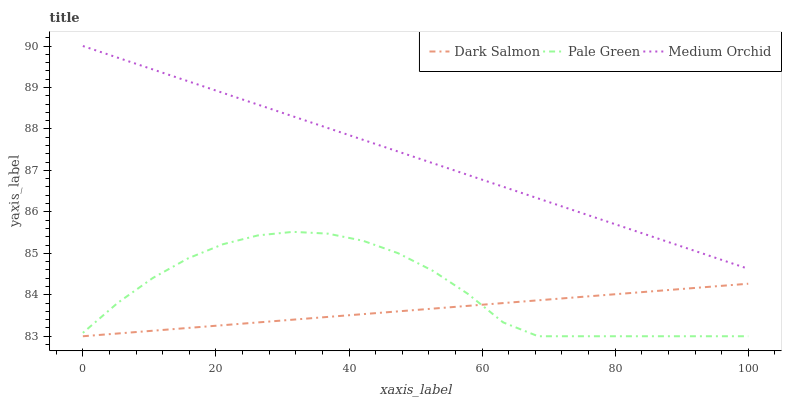Does Dark Salmon have the minimum area under the curve?
Answer yes or no. Yes. Does Medium Orchid have the maximum area under the curve?
Answer yes or no. Yes. Does Pale Green have the minimum area under the curve?
Answer yes or no. No. Does Pale Green have the maximum area under the curve?
Answer yes or no. No. Is Dark Salmon the smoothest?
Answer yes or no. Yes. Is Pale Green the roughest?
Answer yes or no. Yes. Is Pale Green the smoothest?
Answer yes or no. No. Is Dark Salmon the roughest?
Answer yes or no. No. Does Pale Green have the lowest value?
Answer yes or no. Yes. Does Medium Orchid have the highest value?
Answer yes or no. Yes. Does Pale Green have the highest value?
Answer yes or no. No. Is Pale Green less than Medium Orchid?
Answer yes or no. Yes. Is Medium Orchid greater than Dark Salmon?
Answer yes or no. Yes. Does Pale Green intersect Dark Salmon?
Answer yes or no. Yes. Is Pale Green less than Dark Salmon?
Answer yes or no. No. Is Pale Green greater than Dark Salmon?
Answer yes or no. No. Does Pale Green intersect Medium Orchid?
Answer yes or no. No. 